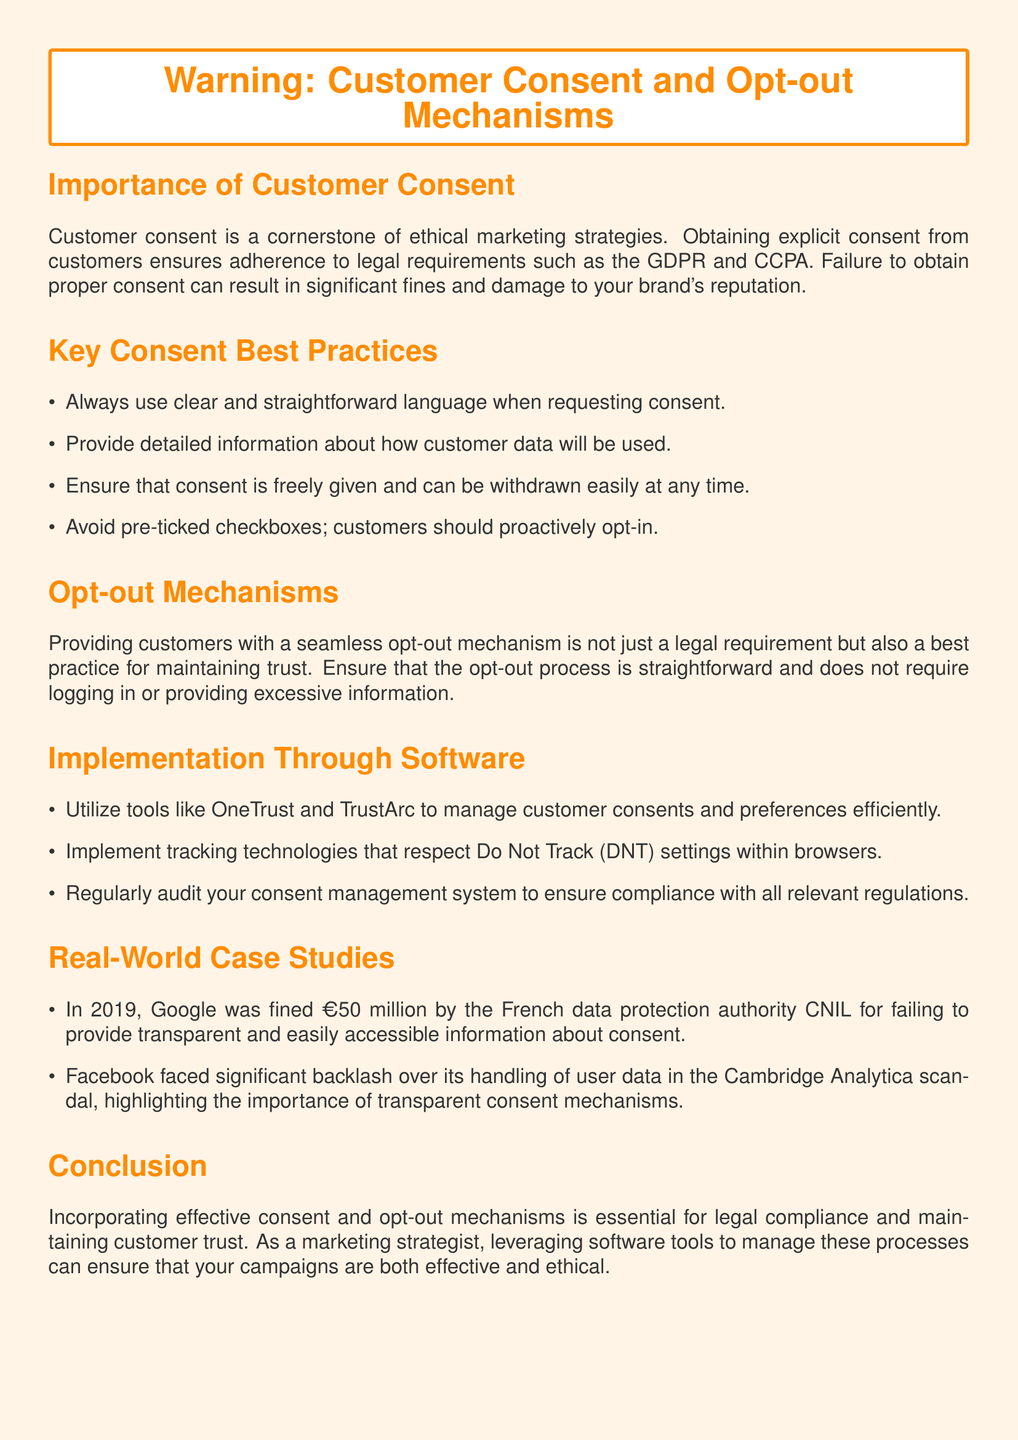What is the color used for the warning label background? The color specified for the warning label background in the document is a light shade identified by RGB values.
Answer: RGB(255,244,230) What is the legal framework mentioned for obtaining customer consent? The document references two key legal frameworks that govern customer consent practices.
Answer: GDPR and CCPA What should be avoided when requesting customer consent? The document specifically advises against a particular aspect of consent mechanisms that does not allow customers to actively choose.
Answer: Pre-ticked checkboxes What year was Google fined for consent issues? The document cites a specific year related to a major fine imposed on Google due to consent-related failures.
Answer: 2019 What tools are recommended for managing customer consents? The document provides examples of software tools that help manage customer consent effectively.
Answer: OneTrust and TrustArc What must customers be able to do concerning their consent? The document emphasizes a particular right that customers should have concerning their consent.
Answer: Withdraw easily In which country did Google face a fine related to consent? The document mentions the name of the authority that fined Google, indicating the country where this occurred.
Answer: France What is the primary focus of the document? The document's main theme revolves around a critical aspect of marketing strategies concerning customer interactions.
Answer: Customer Consent and Opt-out Mechanisms 